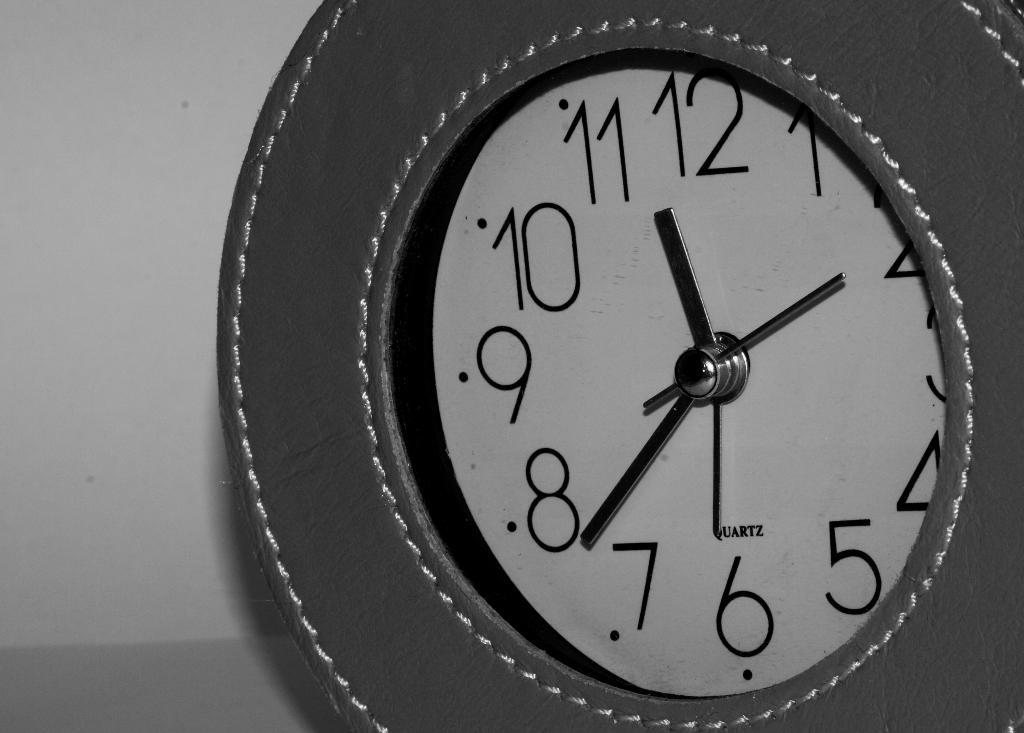<image>
Describe the image concisely. an analog clock that reads Quartz on the front 